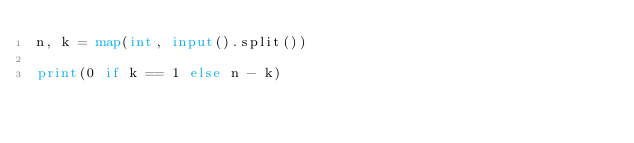Convert code to text. <code><loc_0><loc_0><loc_500><loc_500><_Python_>n, k = map(int, input().split())

print(0 if k == 1 else n - k)</code> 